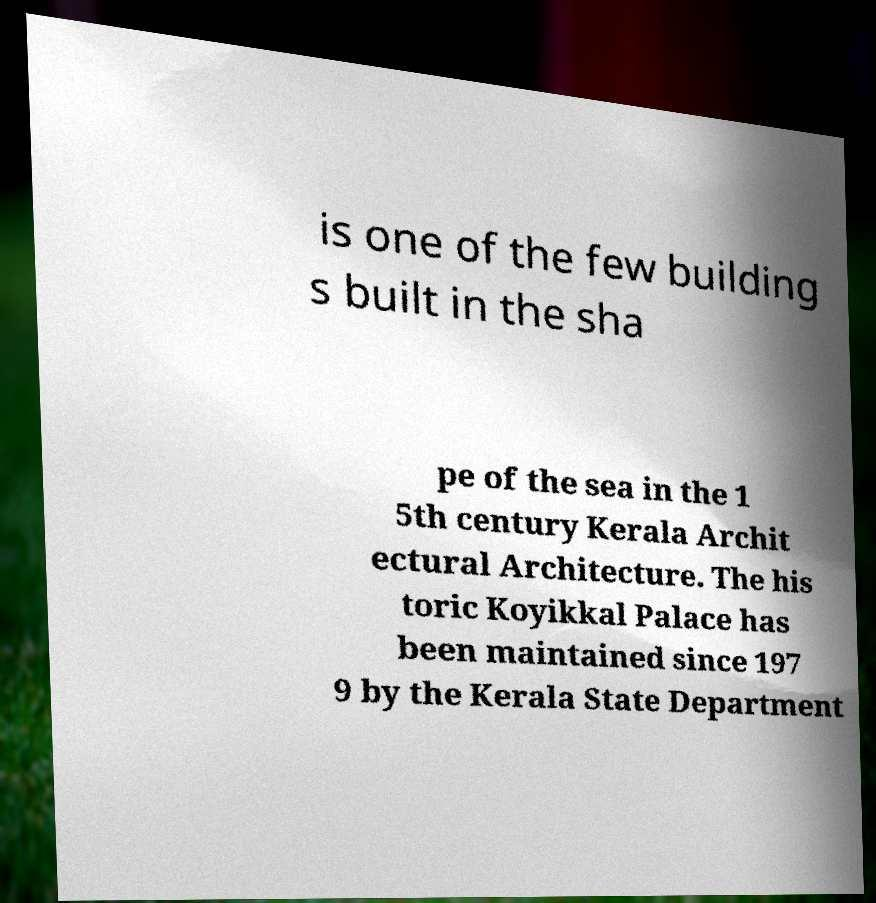Can you accurately transcribe the text from the provided image for me? is one of the few building s built in the sha pe of the sea in the 1 5th century Kerala Archit ectural Architecture. The his toric Koyikkal Palace has been maintained since 197 9 by the Kerala State Department 